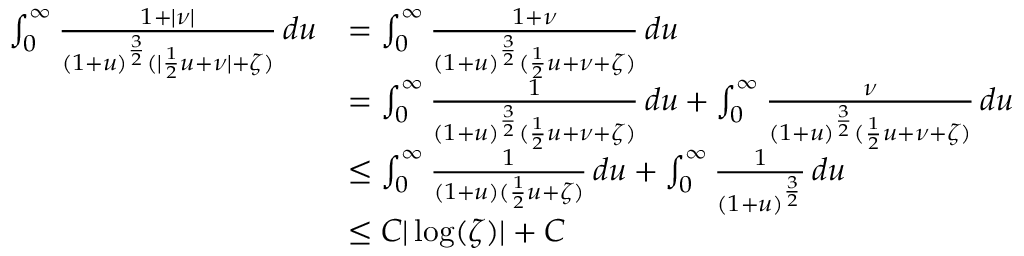Convert formula to latex. <formula><loc_0><loc_0><loc_500><loc_500>\begin{array} { r l } { \int _ { 0 } ^ { \infty } \frac { 1 + | \nu | } { ( 1 + u ) ^ { \frac { 3 } { 2 } } ( | \frac { 1 } { 2 } u + \nu | + \zeta ) } \, d u } & { = \int _ { 0 } ^ { \infty } \frac { 1 + \nu } { ( 1 + u ) ^ { \frac { 3 } { 2 } } ( \frac { 1 } { 2 } u + \nu + \zeta ) } \, d u } \\ & { = \int _ { 0 } ^ { \infty } \frac { 1 } { ( 1 + u ) ^ { \frac { 3 } { 2 } } ( \frac { 1 } { 2 } u + \nu + \zeta ) } \, d u + \int _ { 0 } ^ { \infty } \frac { \nu } { ( 1 + u ) ^ { \frac { 3 } { 2 } } ( \frac { 1 } { 2 } u + \nu + \zeta ) } \, d u } \\ & { \leq \int _ { 0 } ^ { \infty } \frac { 1 } { ( 1 + u ) ( \frac { 1 } { 2 } u + \zeta ) } \, d u + \int _ { 0 } ^ { \infty } \frac { 1 } { ( 1 + u ) ^ { \frac { 3 } { 2 } } } \, d u } \\ & { \leq C | \log ( \zeta ) | + C } \end{array}</formula> 